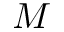Convert formula to latex. <formula><loc_0><loc_0><loc_500><loc_500>M</formula> 